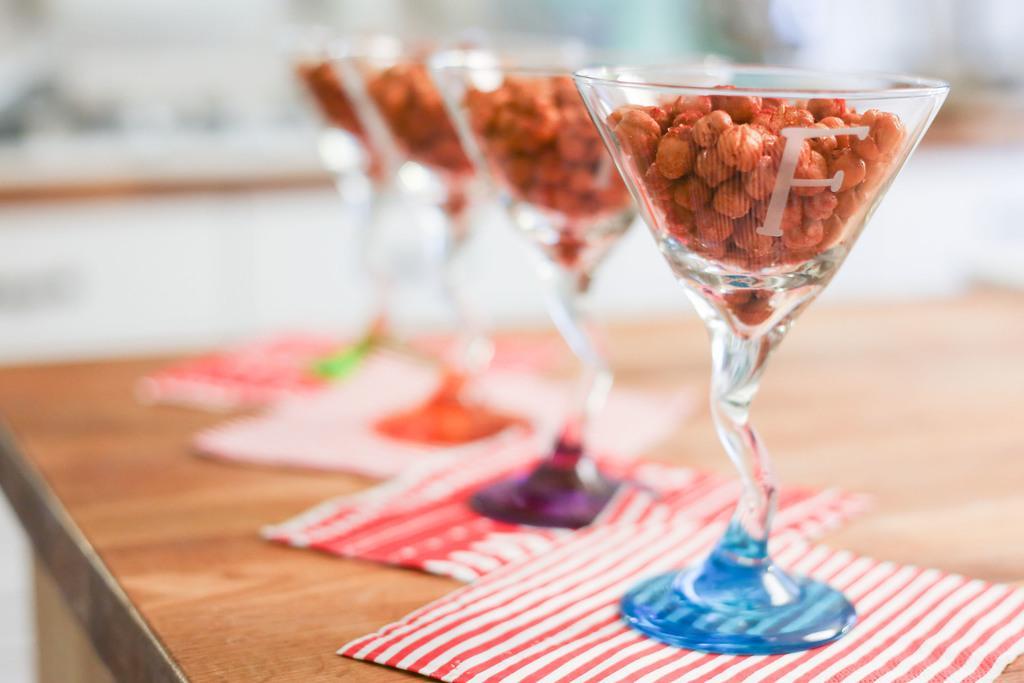In one or two sentences, can you explain what this image depicts? In the table we can see tissue papers, wine glasses and seeds. On the background we can see white color wall. 